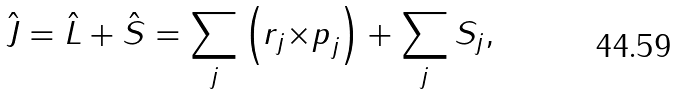Convert formula to latex. <formula><loc_0><loc_0><loc_500><loc_500>\hat { J } = \hat { L } + \hat { S } = \sum _ { j } \left ( { r } _ { j } { \times p } _ { j } \right ) + \sum _ { j } { S } _ { j } ,</formula> 